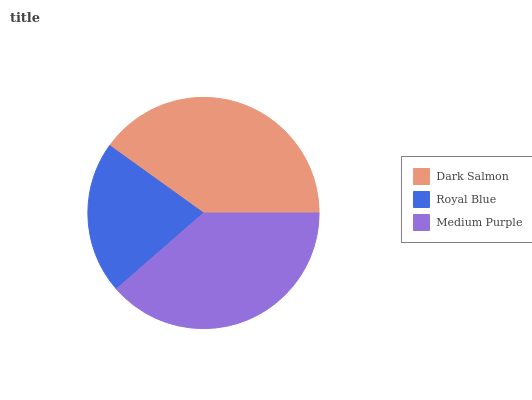Is Royal Blue the minimum?
Answer yes or no. Yes. Is Dark Salmon the maximum?
Answer yes or no. Yes. Is Medium Purple the minimum?
Answer yes or no. No. Is Medium Purple the maximum?
Answer yes or no. No. Is Medium Purple greater than Royal Blue?
Answer yes or no. Yes. Is Royal Blue less than Medium Purple?
Answer yes or no. Yes. Is Royal Blue greater than Medium Purple?
Answer yes or no. No. Is Medium Purple less than Royal Blue?
Answer yes or no. No. Is Medium Purple the high median?
Answer yes or no. Yes. Is Medium Purple the low median?
Answer yes or no. Yes. Is Royal Blue the high median?
Answer yes or no. No. Is Royal Blue the low median?
Answer yes or no. No. 